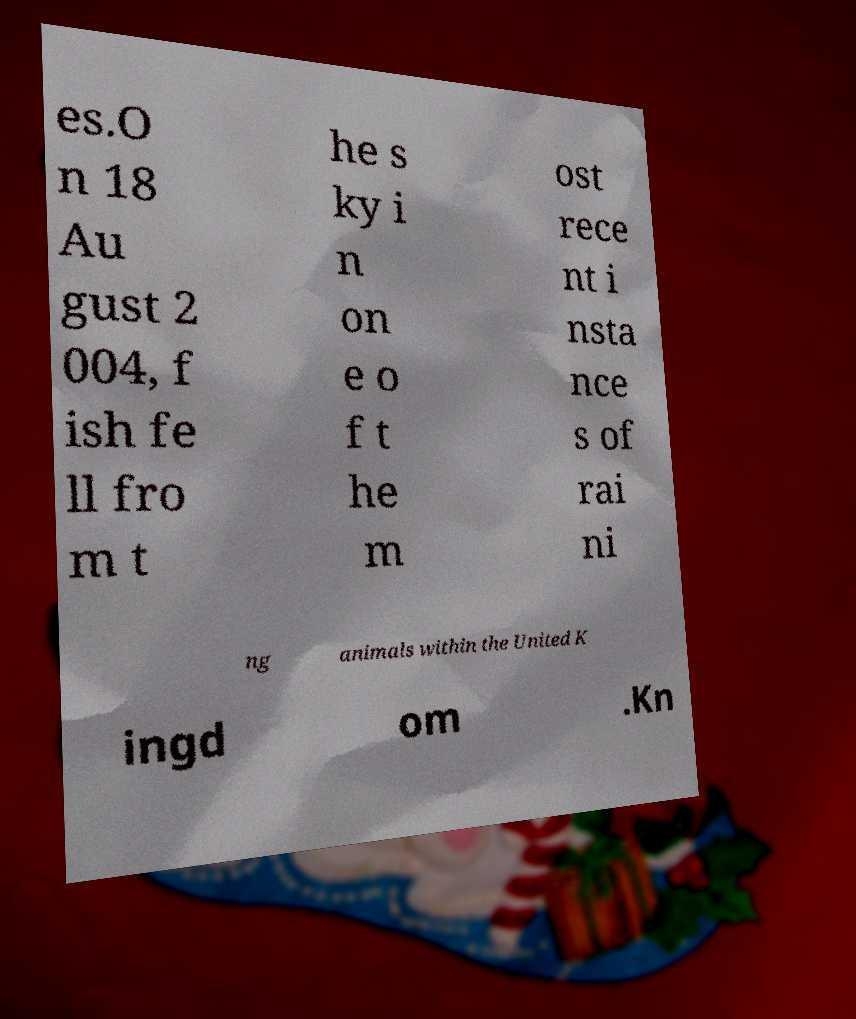Please read and relay the text visible in this image. What does it say? es.O n 18 Au gust 2 004, f ish fe ll fro m t he s ky i n on e o f t he m ost rece nt i nsta nce s of rai ni ng animals within the United K ingd om .Kn 